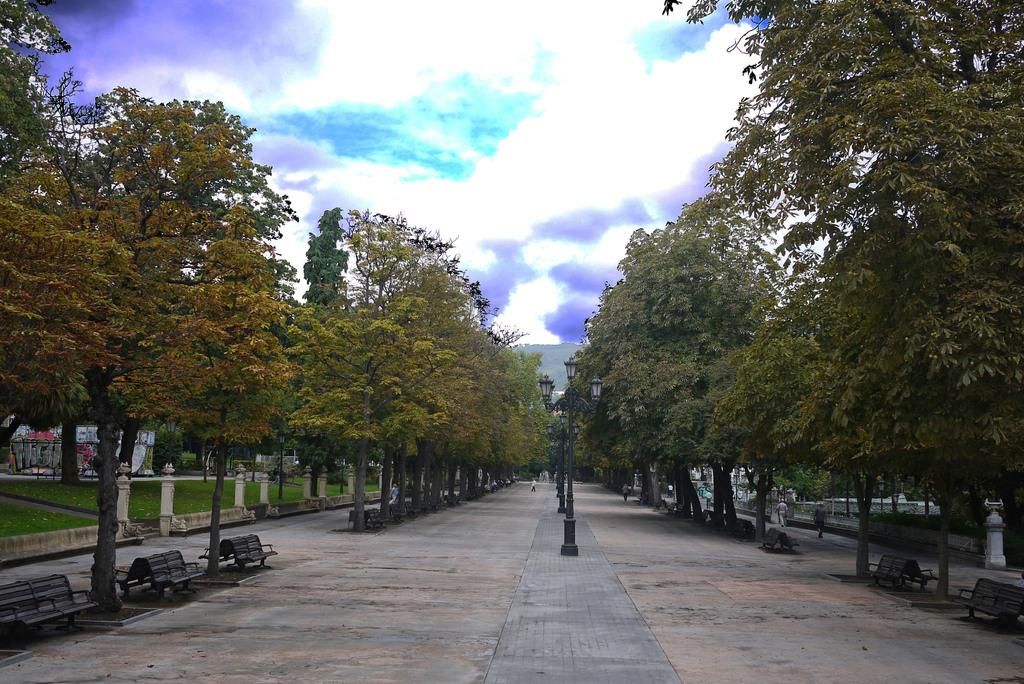What can be seen in the foreground of the image? In the foreground of the image, there is a path and poles. What is located on either side of the path? There are benches on either side of the path. What type of vegetation is present on either side of the path? Trees are present on either side of the path. What else can be seen in the image besides the path and trees? Greenery is visible in the image. What is visible at the top of the image? The sky is visible at the top of the image. Where is the nest of fairies located in the image? There is no nest of fairies present in the image. Can you tell me how many sinks are visible in the image? There are no sinks visible in the image. 